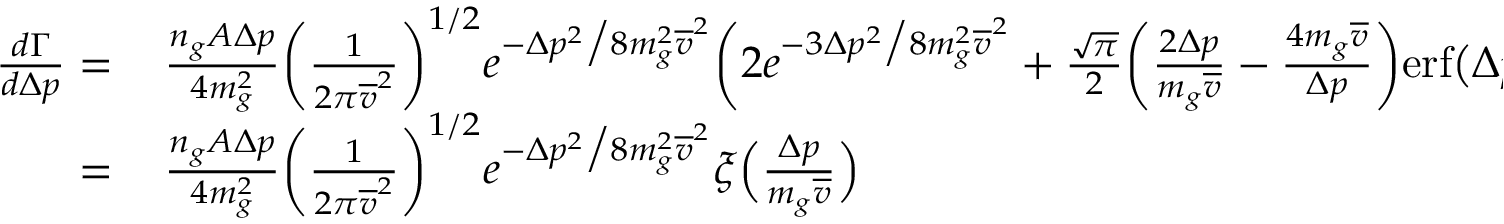<formula> <loc_0><loc_0><loc_500><loc_500>\begin{array} { r l } { \frac { d \Gamma } { d \Delta p } = } & \, \frac { n _ { g } A \Delta p } { 4 m _ { g } ^ { 2 } } \left ( \frac { 1 } { 2 \pi \overline { v } ^ { 2 } } \right ) ^ { 1 / 2 } e ^ { - \Delta p ^ { 2 } \Big / 8 m _ { g } ^ { 2 } \overline { v } ^ { 2 } } \left ( 2 e ^ { - 3 \Delta p ^ { 2 } \Big / 8 m _ { g } ^ { 2 } \overline { v } ^ { 2 } } + \frac { \sqrt { \pi } } { 2 } \left ( \frac { 2 \Delta p } { m _ { g } \overline { v } } - \frac { 4 m _ { g } \overline { v } } { \Delta p } \right ) e r f \left ( \Delta p / 2 m _ { g } \overline { v } \right ) e ^ { - \Delta p ^ { 2 } \Big / 8 m _ { g } ^ { 2 } \overline { v } ^ { 2 } } \right ) } \\ { = } & \, \frac { n _ { g } A \Delta p } { 4 m _ { g } ^ { 2 } } \left ( \frac { 1 } { 2 \pi \overline { v } ^ { 2 } } \right ) ^ { 1 / 2 } e ^ { - \Delta p ^ { 2 } \Big / 8 m _ { g } ^ { 2 } \overline { v } ^ { 2 } } \xi \left ( \frac { \Delta p } { m _ { g } \overline { v } } \right ) } \end{array}</formula> 